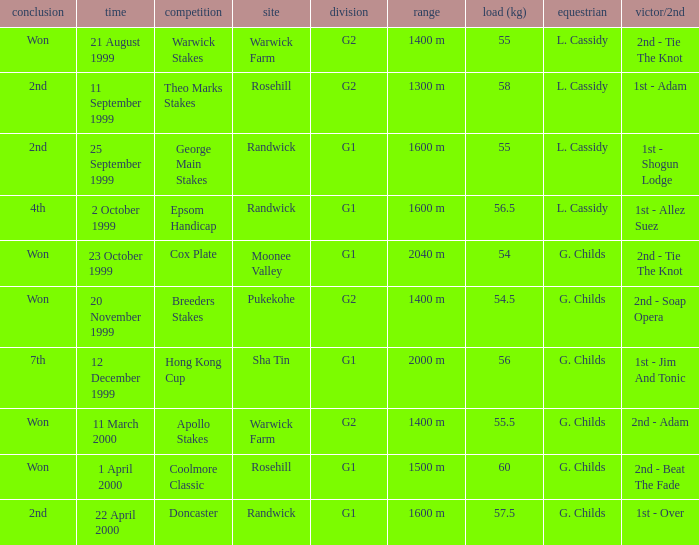How man teams had a total weight of 57.5? 1.0. Help me parse the entirety of this table. {'header': ['conclusion', 'time', 'competition', 'site', 'division', 'range', 'load (kg)', 'equestrian', 'victor/2nd'], 'rows': [['Won', '21 August 1999', 'Warwick Stakes', 'Warwick Farm', 'G2', '1400 m', '55', 'L. Cassidy', '2nd - Tie The Knot'], ['2nd', '11 September 1999', 'Theo Marks Stakes', 'Rosehill', 'G2', '1300 m', '58', 'L. Cassidy', '1st - Adam'], ['2nd', '25 September 1999', 'George Main Stakes', 'Randwick', 'G1', '1600 m', '55', 'L. Cassidy', '1st - Shogun Lodge'], ['4th', '2 October 1999', 'Epsom Handicap', 'Randwick', 'G1', '1600 m', '56.5', 'L. Cassidy', '1st - Allez Suez'], ['Won', '23 October 1999', 'Cox Plate', 'Moonee Valley', 'G1', '2040 m', '54', 'G. Childs', '2nd - Tie The Knot'], ['Won', '20 November 1999', 'Breeders Stakes', 'Pukekohe', 'G2', '1400 m', '54.5', 'G. Childs', '2nd - Soap Opera'], ['7th', '12 December 1999', 'Hong Kong Cup', 'Sha Tin', 'G1', '2000 m', '56', 'G. Childs', '1st - Jim And Tonic'], ['Won', '11 March 2000', 'Apollo Stakes', 'Warwick Farm', 'G2', '1400 m', '55.5', 'G. Childs', '2nd - Adam'], ['Won', '1 April 2000', 'Coolmore Classic', 'Rosehill', 'G1', '1500 m', '60', 'G. Childs', '2nd - Beat The Fade'], ['2nd', '22 April 2000', 'Doncaster', 'Randwick', 'G1', '1600 m', '57.5', 'G. Childs', '1st - Over']]} 